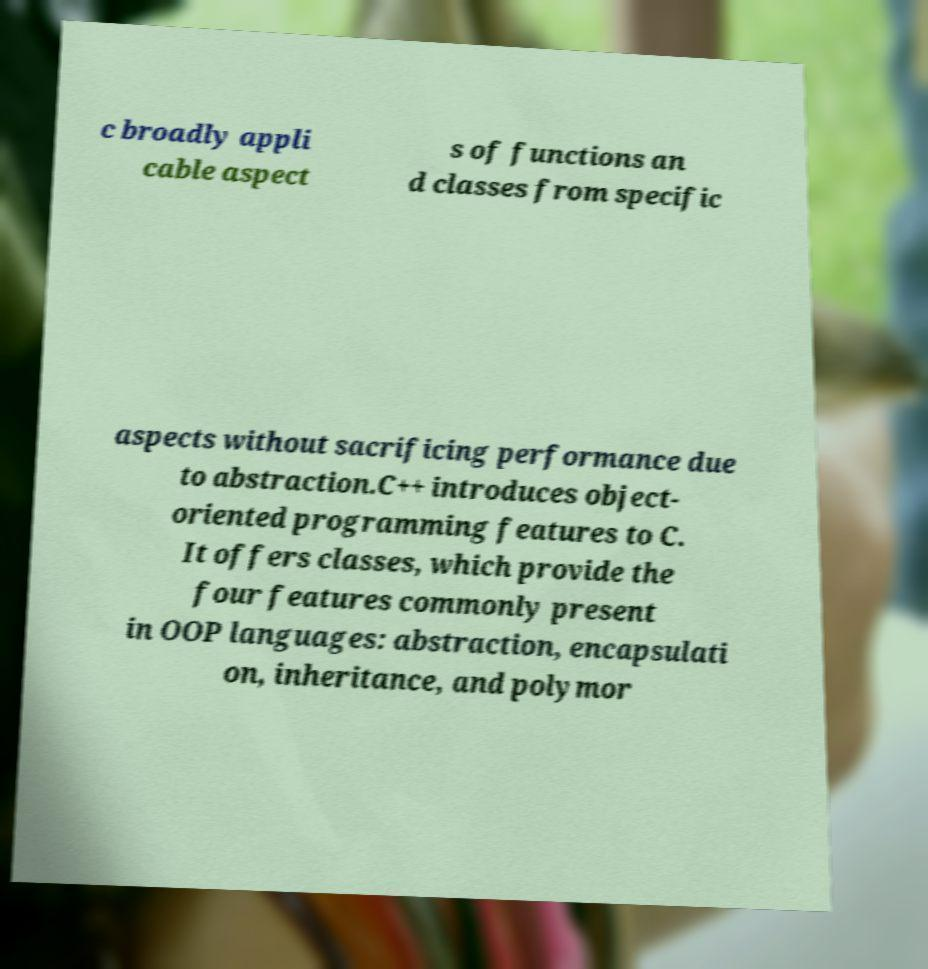What messages or text are displayed in this image? I need them in a readable, typed format. c broadly appli cable aspect s of functions an d classes from specific aspects without sacrificing performance due to abstraction.C++ introduces object- oriented programming features to C. It offers classes, which provide the four features commonly present in OOP languages: abstraction, encapsulati on, inheritance, and polymor 